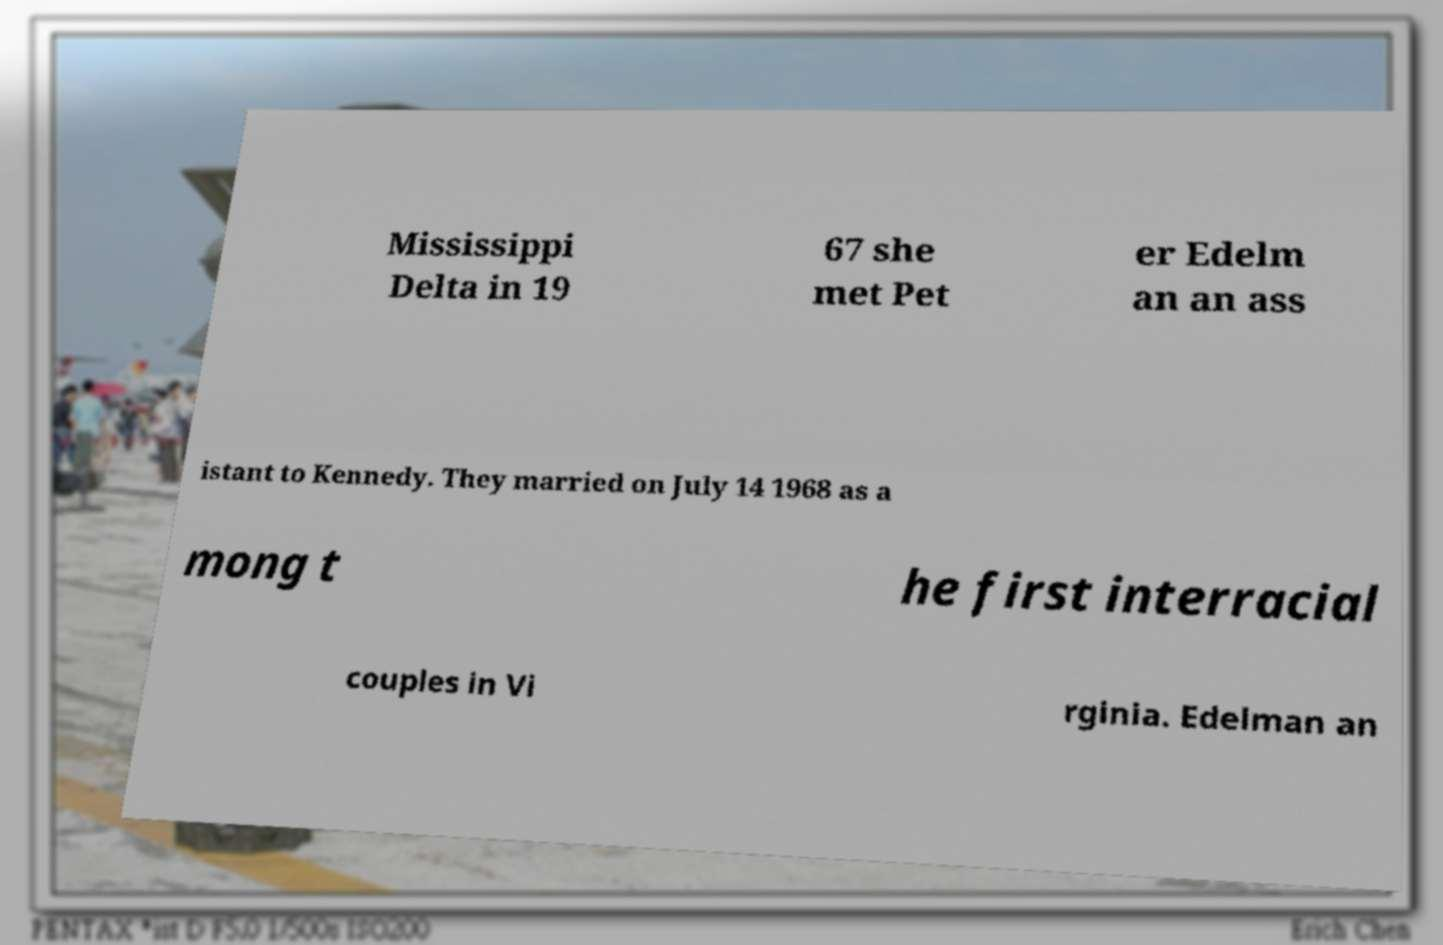Could you assist in decoding the text presented in this image and type it out clearly? Mississippi Delta in 19 67 she met Pet er Edelm an an ass istant to Kennedy. They married on July 14 1968 as a mong t he first interracial couples in Vi rginia. Edelman an 